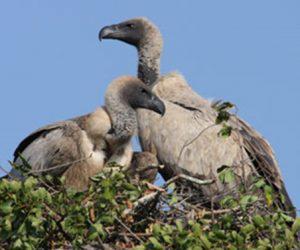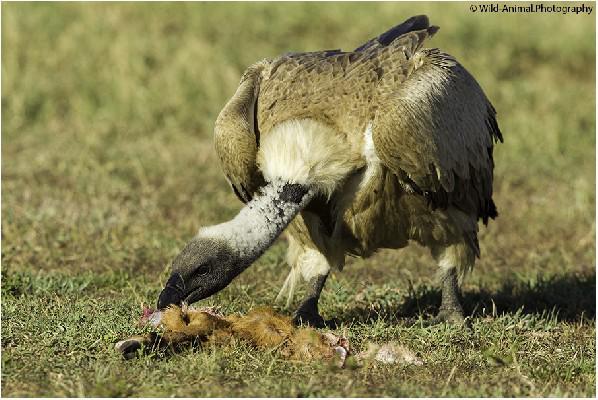The first image is the image on the left, the second image is the image on the right. For the images shown, is this caption "There is no more than three birds." true? Answer yes or no. Yes. 